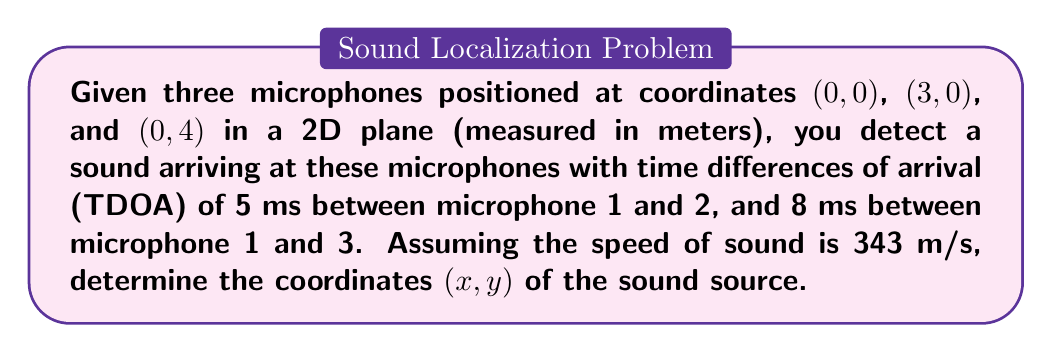Teach me how to tackle this problem. To solve this problem, we'll use the hyperbolic positioning method:

1) First, let's calculate the distance differences based on the TDOA:
   $$d_{12} = 343 \text{ m/s} \times 0.005 \text{ s} = 1.715 \text{ m}$$
   $$d_{13} = 343 \text{ m/s} \times 0.008 \text{ s} = 2.744 \text{ m}$$

2) Now, we can set up two equations based on the distance differences:
   $$\sqrt{x^2 + y^2} - \sqrt{(x-3)^2 + y^2} = 1.715$$
   $$\sqrt{x^2 + y^2} - \sqrt{x^2 + (y-4)^2} = 2.744$$

3) These equations represent hyperbolas. To solve them, we can use a numerical method like Newton-Raphson or a nonlinear least squares solver. However, for this example, we'll use a graphical approach.

4) We can rearrange the equations to:
   $$\sqrt{x^2 + y^2} = \sqrt{(x-3)^2 + y^2} + 1.715$$
   $$\sqrt{x^2 + y^2} = \sqrt{x^2 + (y-4)^2} + 2.744$$

5) Plotting these equations:

[asy]
import graph;
size(200);

real f1(real x, real y) {
  return sqrt(x^2+y^2) - sqrt((x-3)^2+y^2) - 1.715;
}

real f2(real x, real y) {
  return sqrt(x^2+y^2) - sqrt(x^2+(y-4)^2) - 2.744;
}

draw(contour(f1,(-2,-2),(5,6),new real[]{0}),blue);
draw(contour(f2,(-2,-2),(5,6),new real[]{0}),red);

dot((0,0));
dot((3,0));
dot((0,4));
dot((1.5,2.6),red);

label("(0,0)",(0,0),SW);
label("(3,0)",(3,0),SE);
label("(0,4)",(0,4),NW);
label("(1.5,2.6)",(1.5,2.6),NE);
[/asy]

6) The intersection point of these two hyperbolas gives us the location of the sound source. From the graph, we can estimate this point to be approximately (1.5, 2.6).
Answer: (1.5, 2.6) 